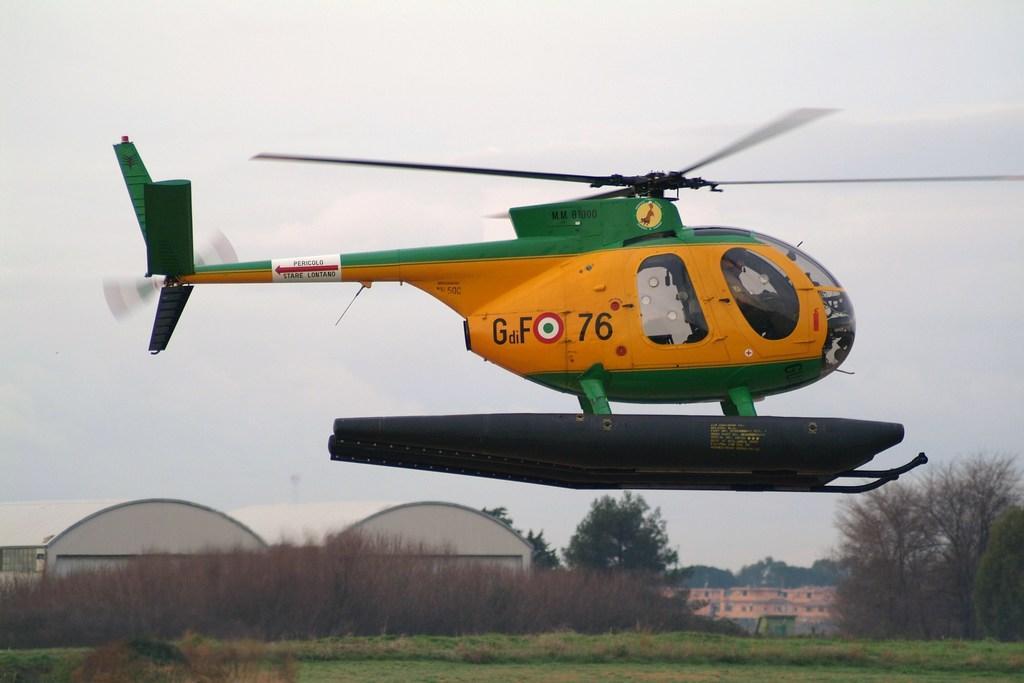In one or two sentences, can you explain what this image depicts? In this image, we can see a helicopter and in the background, there are buildings, sheds and we can see trees. At the bottom, there is ground. 